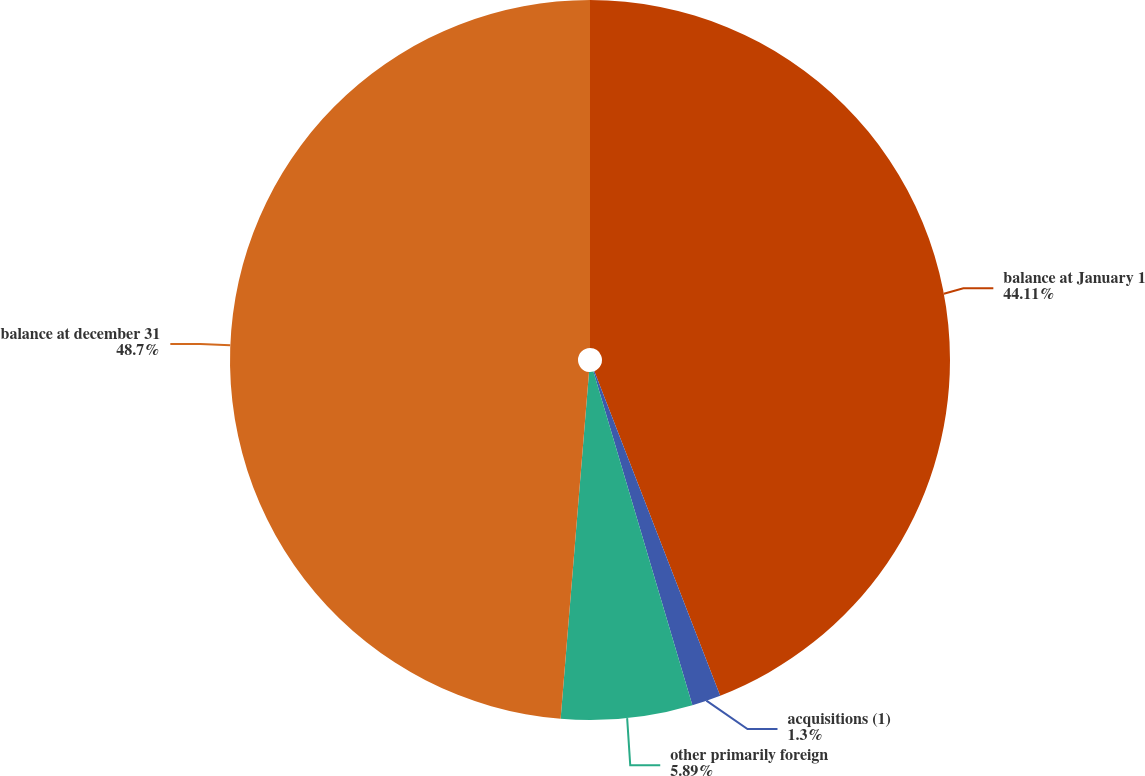Convert chart to OTSL. <chart><loc_0><loc_0><loc_500><loc_500><pie_chart><fcel>balance at January 1<fcel>acquisitions (1)<fcel>other primarily foreign<fcel>balance at december 31<nl><fcel>44.11%<fcel>1.3%<fcel>5.89%<fcel>48.7%<nl></chart> 